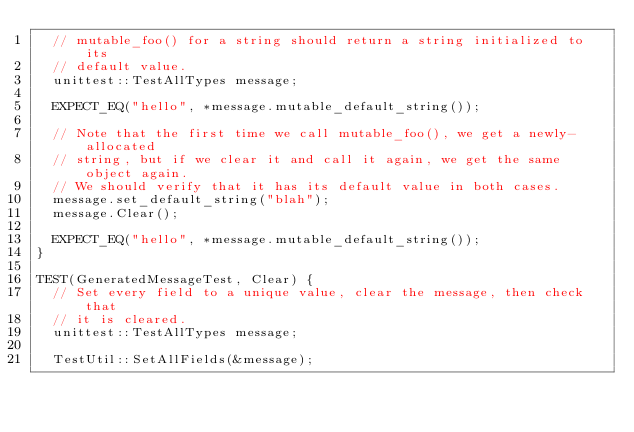<code> <loc_0><loc_0><loc_500><loc_500><_C++_>  // mutable_foo() for a string should return a string initialized to its
  // default value.
  unittest::TestAllTypes message;

  EXPECT_EQ("hello", *message.mutable_default_string());

  // Note that the first time we call mutable_foo(), we get a newly-allocated
  // string, but if we clear it and call it again, we get the same object again.
  // We should verify that it has its default value in both cases.
  message.set_default_string("blah");
  message.Clear();

  EXPECT_EQ("hello", *message.mutable_default_string());
}

TEST(GeneratedMessageTest, Clear) {
  // Set every field to a unique value, clear the message, then check that
  // it is cleared.
  unittest::TestAllTypes message;

  TestUtil::SetAllFields(&message);</code> 